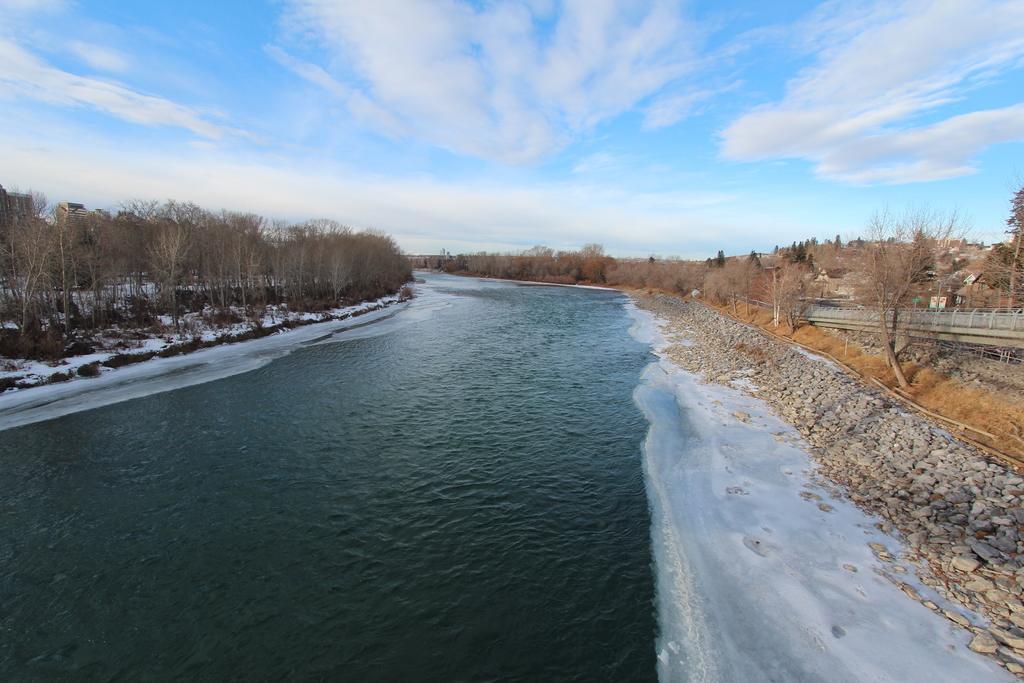Could you give a brief overview of what you see in this image? In this picture I can see the water and number of stones in the center and I can see number of tree on both the sides of this picture. In the background I can see the sky. 